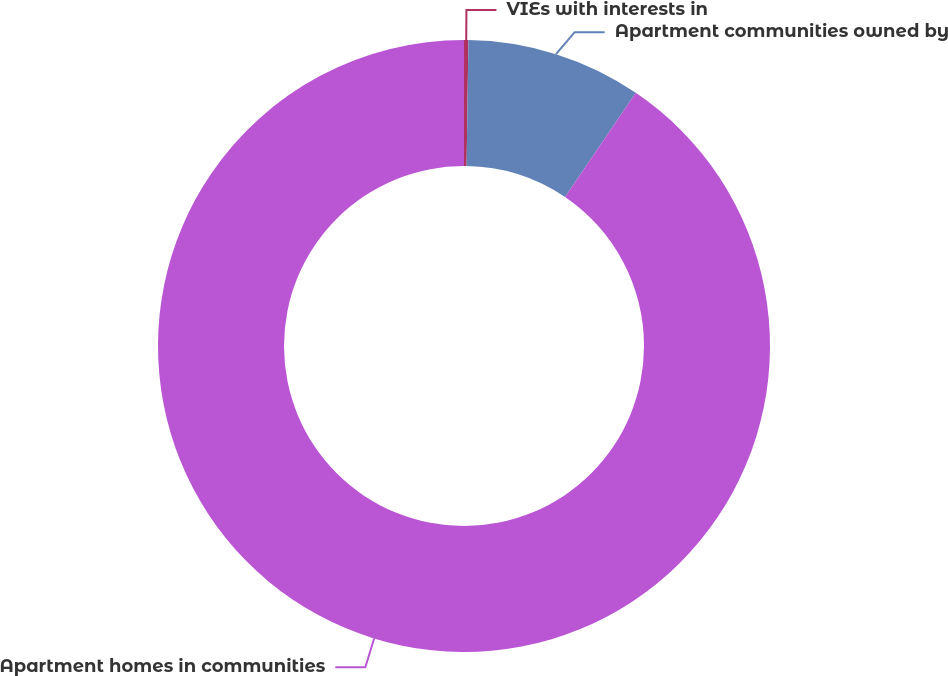Convert chart. <chart><loc_0><loc_0><loc_500><loc_500><pie_chart><fcel>VIEs with interests in<fcel>Apartment communities owned by<fcel>Apartment homes in communities<nl><fcel>0.23%<fcel>9.26%<fcel>90.52%<nl></chart> 